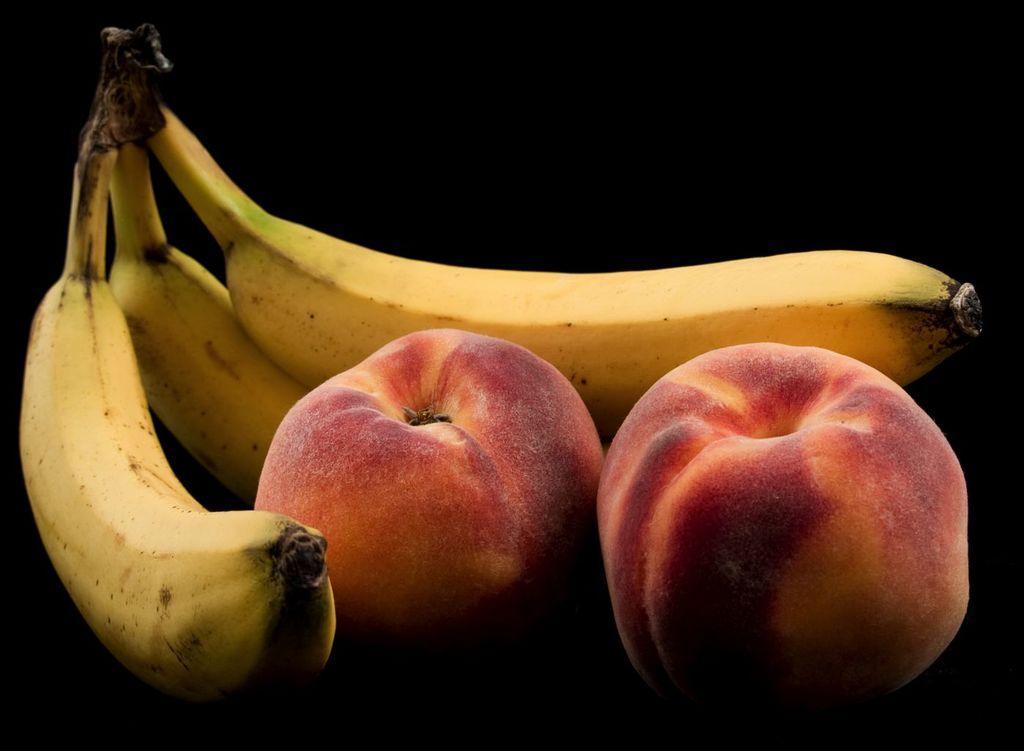Could you give a brief overview of what you see in this image? In this image we see three bananas and apples. Background it is in black color.  